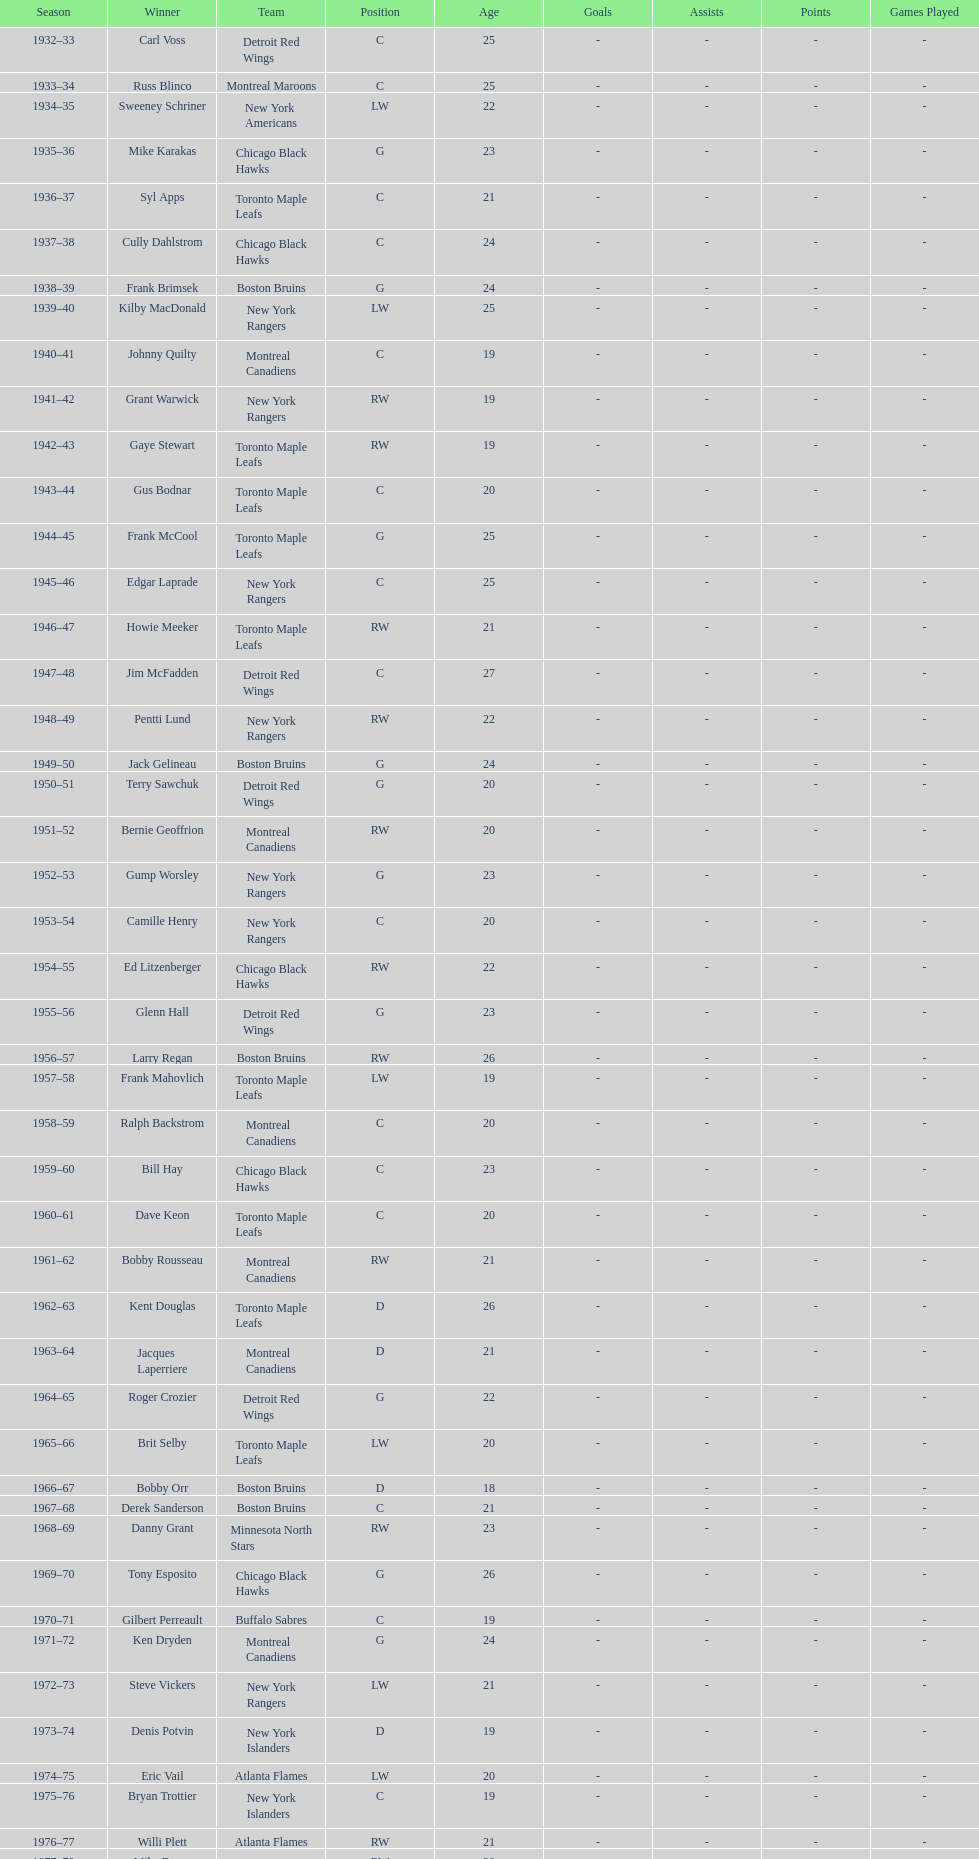Who was the first calder memorial trophy winner from the boston bruins? Frank Brimsek. 